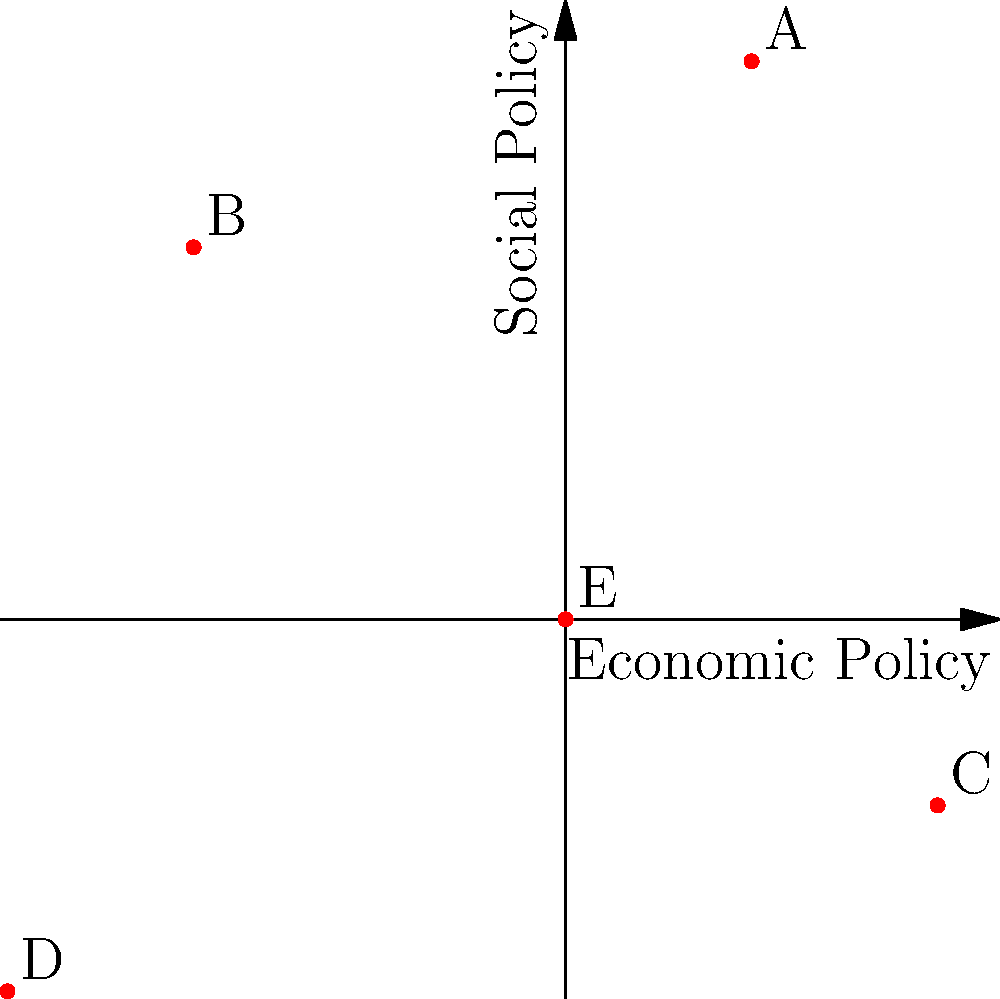In the scatter plot above, political ideologies are represented on a 2D plane where the x-axis represents economic policy (right is more conservative) and the y-axis represents social policy (up is more liberal). Which two ideologies would you expect to be clustered together based on their proximity? To answer this question, we need to analyze the relative positions of the points on the scatter plot:

1. Point A (1, 3): Slightly conservative economically, very liberal socially
2. Point B (-2, 2): Liberal economically, liberal socially
3. Point C (2, -1): Conservative economically, slightly conservative socially
4. Point D (-3, -2): Very liberal economically, conservative socially
5. Point E (0, 0): Centrist on both economic and social policies

To determine which ideologies are clustered together, we need to find the two points that are closest to each other in the 2D space. By visual inspection, we can see that points A and B are the closest pair.

To confirm this, we could calculate the Euclidean distance between each pair of points using the formula:

$$ d = \sqrt{(x_2 - x_1)^2 + (y_2 - y_1)^2} $$

However, for this question, a visual assessment is sufficient to determine that A and B are the closest pair.

Both A and B are in the upper half of the plot, indicating liberal social policies. They are also relatively close on the economic axis, with A being slightly conservative and B being liberal. This suggests that these two ideologies share similar views on social issues and have somewhat close positions on economic issues.
Answer: A and B 